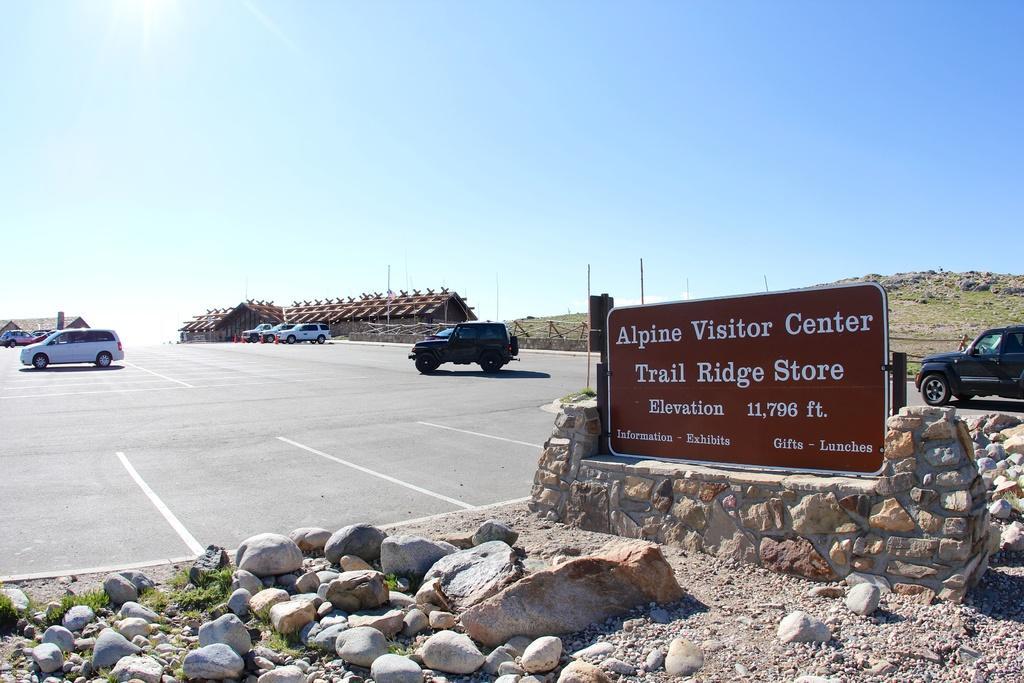Could you give a brief overview of what you see in this image? Here in the front we can see a board present on a wall over there and we can see some stones present on the ground over there and we can also see some grass also present over there and on the road we can see number of vehicles present here and there and in the far we can see sheds present here and there and on the right side we can see mountain, which is fully covered with grass over there. 